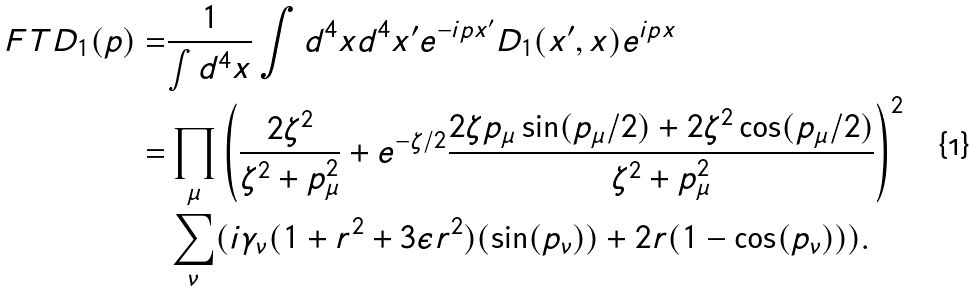Convert formula to latex. <formula><loc_0><loc_0><loc_500><loc_500>\ F T { D _ { 1 } } ( p ) = & \frac { 1 } { \int d ^ { 4 } x } \int d ^ { 4 } x d ^ { 4 } x ^ { \prime } e ^ { - i p x ^ { \prime } } D _ { 1 } ( x ^ { \prime } , x ) e ^ { i p x } \\ = & \prod _ { \mu } \left ( \frac { 2 \zeta ^ { 2 } } { \zeta ^ { 2 } + p _ { \mu } ^ { 2 } } + e ^ { - \zeta / 2 } \frac { 2 \zeta p _ { \mu } \sin ( p _ { \mu } / 2 ) + 2 \zeta ^ { 2 } \cos ( p _ { \mu } / 2 ) } { \zeta ^ { 2 } + p _ { \mu } ^ { 2 } } \right ) ^ { 2 } \\ & \sum _ { \nu } ( i \gamma _ { \nu } ( 1 + r ^ { 2 } + 3 \epsilon r ^ { 2 } ) ( \sin ( p _ { \nu } ) ) + 2 r ( 1 - \cos ( p _ { \nu } ) ) ) .</formula> 